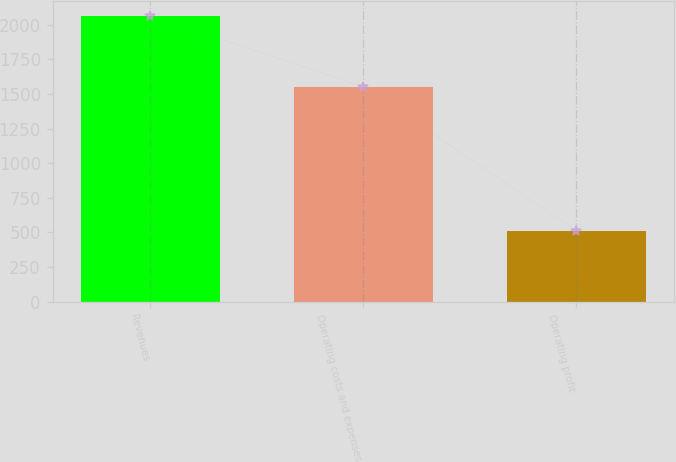Convert chart. <chart><loc_0><loc_0><loc_500><loc_500><bar_chart><fcel>Revenues<fcel>Operating costs and expenses<fcel>Operating profit<nl><fcel>2066<fcel>1553<fcel>513<nl></chart> 